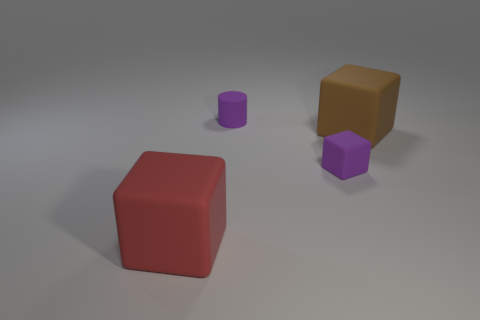Subtract all large red cubes. How many cubes are left? 2 Subtract all purple blocks. How many blocks are left? 2 Subtract all cylinders. How many objects are left? 3 Subtract 1 cubes. How many cubes are left? 2 Add 3 purple blocks. How many purple blocks exist? 4 Add 4 big purple balls. How many objects exist? 8 Subtract 0 blue blocks. How many objects are left? 4 Subtract all yellow blocks. Subtract all green spheres. How many blocks are left? 3 Subtract all yellow cylinders. How many green cubes are left? 0 Subtract all large things. Subtract all large green metallic blocks. How many objects are left? 2 